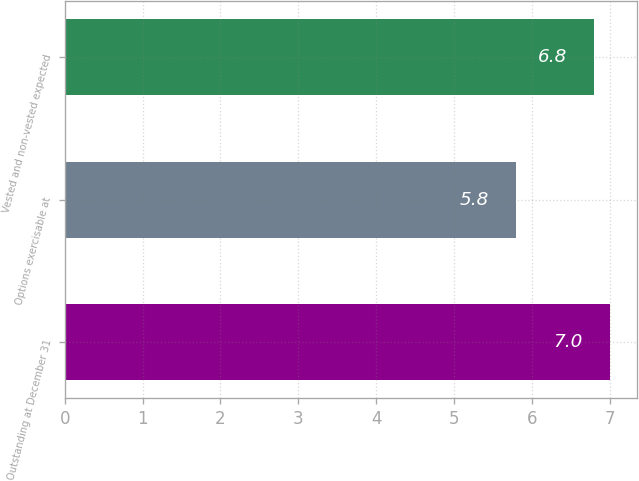Convert chart. <chart><loc_0><loc_0><loc_500><loc_500><bar_chart><fcel>Outstanding at December 31<fcel>Options exercisable at<fcel>Vested and non-vested expected<nl><fcel>7<fcel>5.8<fcel>6.8<nl></chart> 